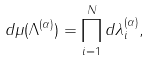Convert formula to latex. <formula><loc_0><loc_0><loc_500><loc_500>d \mu ( \Lambda ^ { ( \alpha ) } ) = \prod _ { i = 1 } ^ { N } d \lambda _ { i } ^ { ( \alpha ) } ,</formula> 